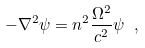Convert formula to latex. <formula><loc_0><loc_0><loc_500><loc_500>- \nabla ^ { 2 } \psi = n ^ { 2 } \frac { \Omega ^ { 2 } } { c ^ { 2 } } \psi \ ,</formula> 